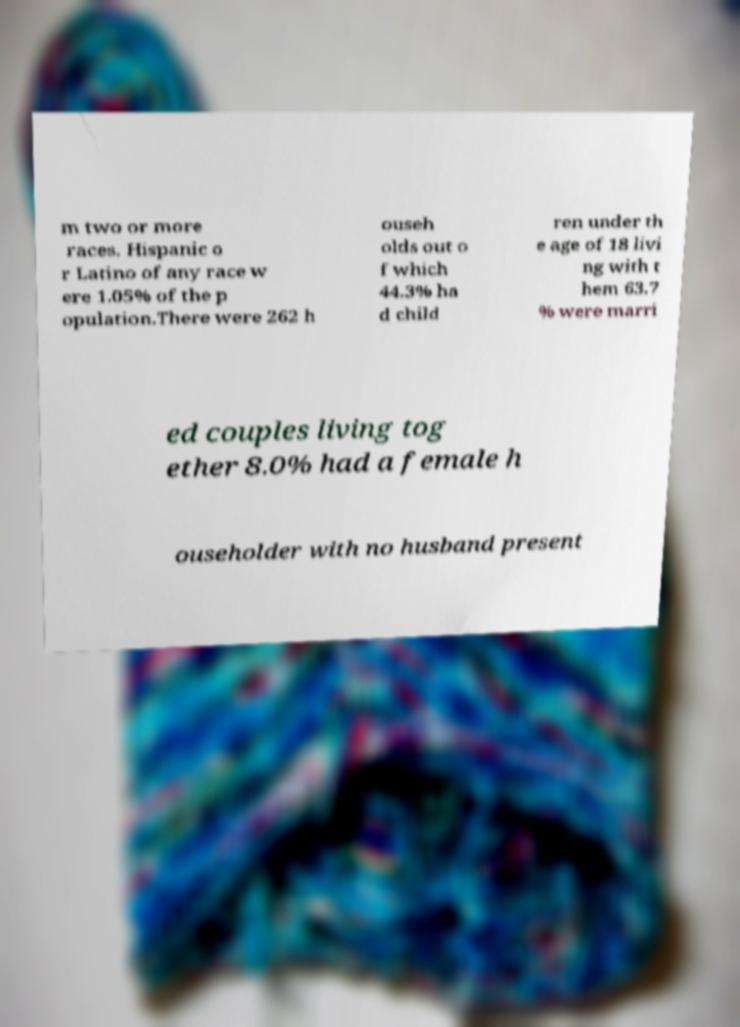Please identify and transcribe the text found in this image. m two or more races. Hispanic o r Latino of any race w ere 1.05% of the p opulation.There were 262 h ouseh olds out o f which 44.3% ha d child ren under th e age of 18 livi ng with t hem 63.7 % were marri ed couples living tog ether 8.0% had a female h ouseholder with no husband present 